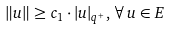Convert formula to latex. <formula><loc_0><loc_0><loc_500><loc_500>\| u \| \geq c _ { 1 } \cdot | u | _ { q ^ { + } } , \, \forall \, u \in E</formula> 